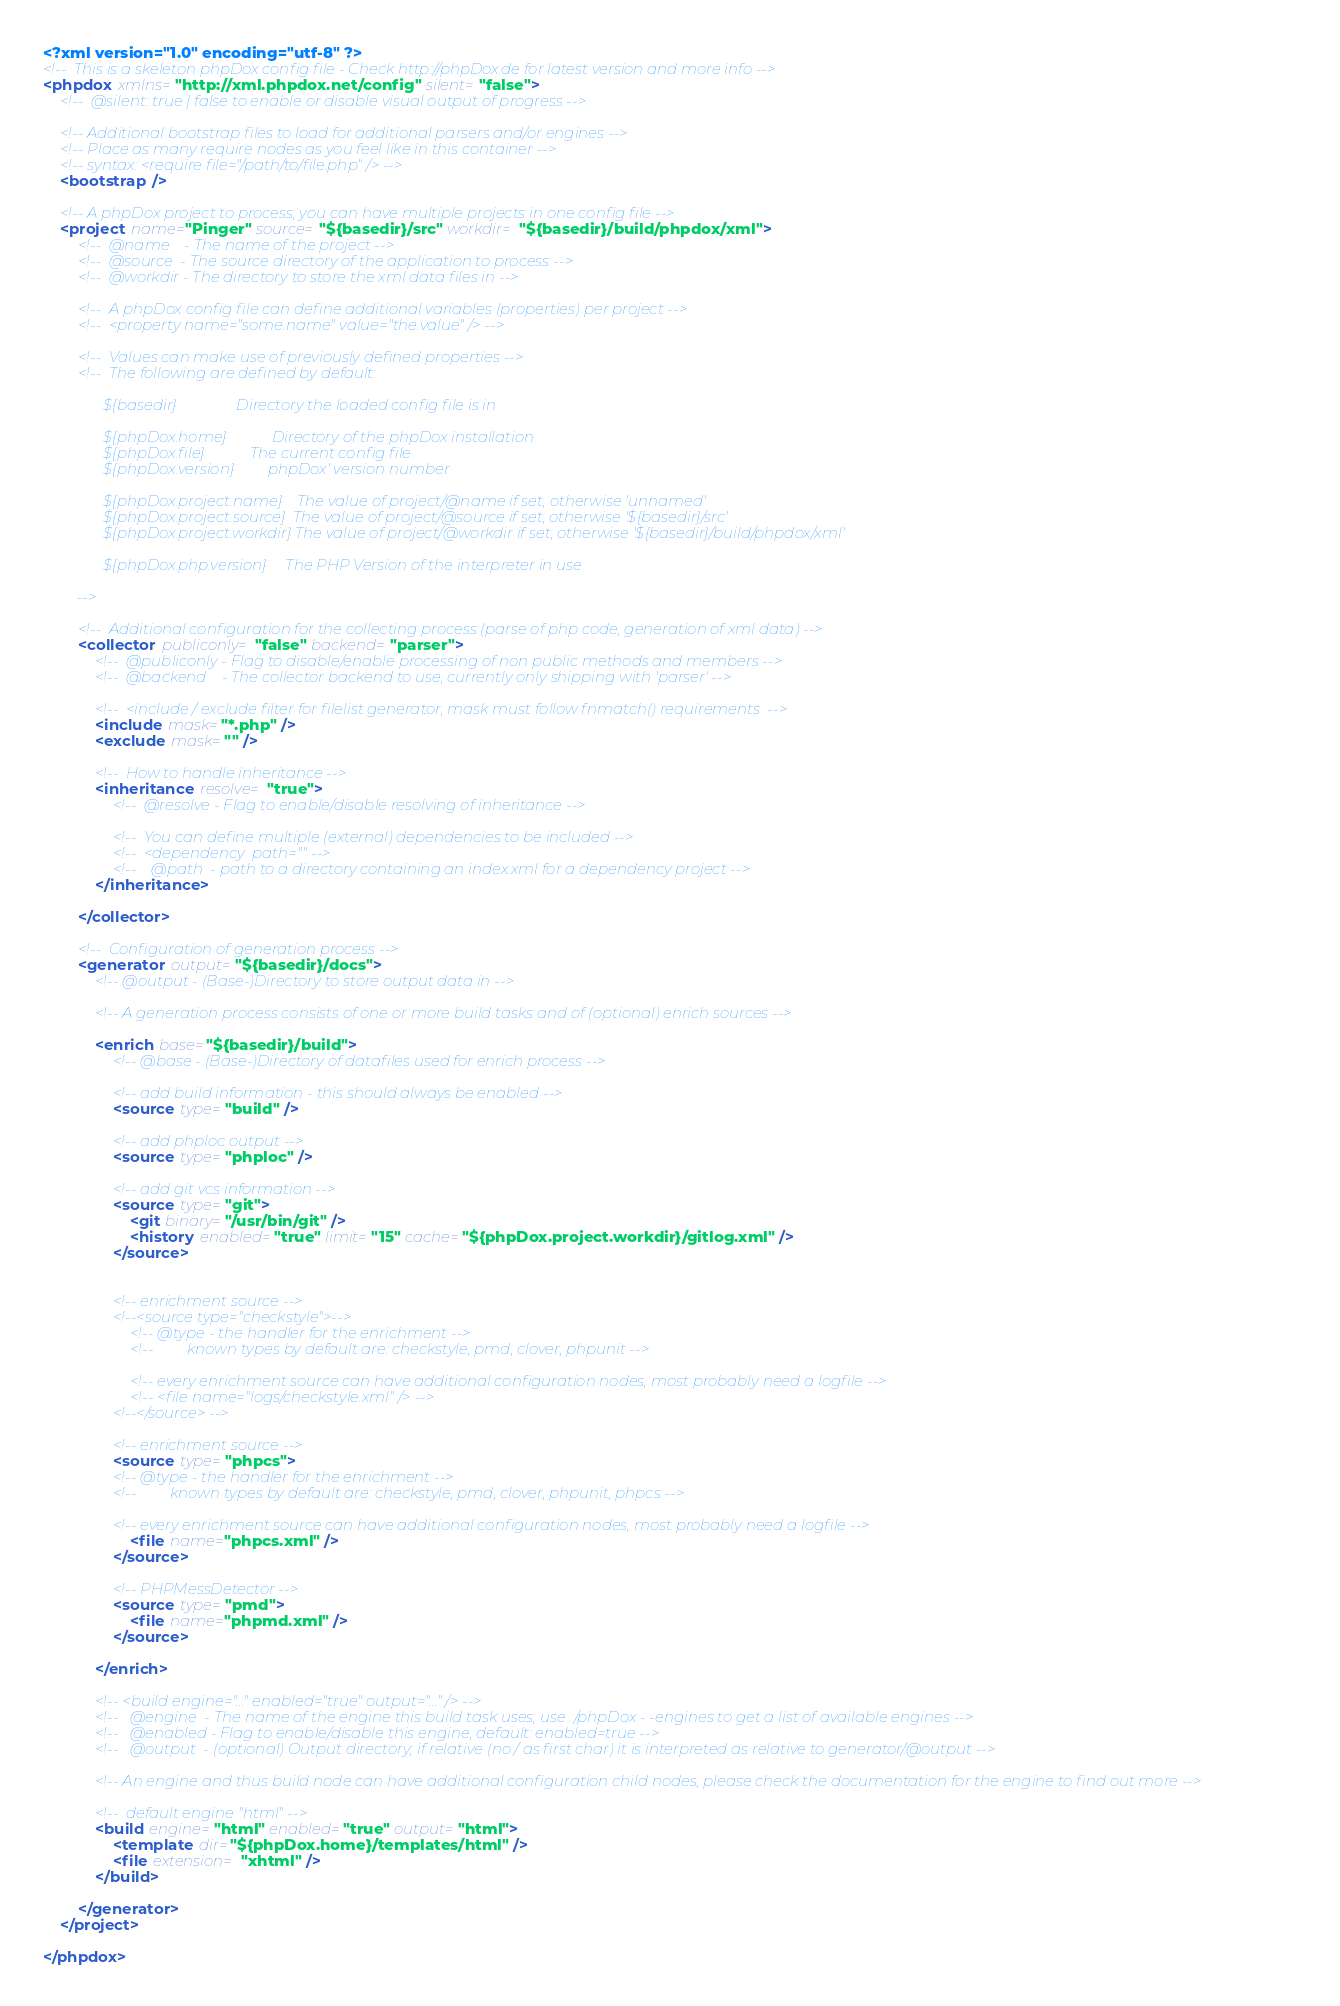Convert code to text. <code><loc_0><loc_0><loc_500><loc_500><_XML_><?xml version="1.0" encoding="utf-8" ?>
<!--  This is a skeleton phpDox config file - Check http://phpDox.de for latest version and more info -->
<phpdox xmlns="http://xml.phpdox.net/config" silent="false">
    <!--  @silent: true | false to enable or disable visual output of progress -->

    <!-- Additional bootstrap files to load for additional parsers and/or engines -->
    <!-- Place as many require nodes as you feel like in this container -->
    <!-- syntax: <require file="/path/to/file.php" /> -->
    <bootstrap />

    <!-- A phpDox project to process, you can have multiple projects in one config file -->
    <project name="Pinger" source="${basedir}/src" workdir="${basedir}/build/phpdox/xml">
        <!--  @name    - The name of the project -->
        <!--  @source  - The source directory of the application to process -->
        <!--  @workdir - The directory to store the xml data files in -->

        <!--  A phpDox config file can define additional variables (properties) per project -->
        <!--  <property name="some.name" value="the.value" /> -->

        <!--  Values can make use of previously defined properties -->
        <!--  The following are defined by default:

                ${basedir}                Directory the loaded config file is in

                ${phpDox.home}            Directory of the phpDox installation
                ${phpDox.file}            The current config file
                ${phpDox.version}         phpDox' version number

                ${phpDox.project.name}    The value of project/@name if set, otherwise 'unnamed'
                ${phpDox.project.source}  The value of project/@source if set, otherwise '${basedir}/src'
                ${phpDox.project.workdir} The value of project/@workdir if set, otherwise '${basedir}/build/phpdox/xml'

                ${phpDox.php.version}     The PHP Version of the interpreter in use

         -->

        <!--  Additional configuration for the collecting process (parse of php code, generation of xml data) -->
        <collector publiconly="false" backend="parser">
            <!--  @publiconly - Flag to disable/enable processing of non public methods and members -->
            <!--  @backend    - The collector backend to use, currently only shipping with 'parser' -->

            <!--  <include / exclude filter for filelist generator, mask must follow fnmatch() requirements  -->
            <include mask="*.php" />
            <exclude mask="" />

            <!--  How to handle inheritance -->
            <inheritance resolve="true">
                <!--  @resolve - Flag to enable/disable resolving of inheritance -->

                <!--  You can define multiple (external) dependencies to be included -->
                <!--  <dependency  path="" -->
                <!--    @path  - path to a directory containing an index.xml for a dependency project -->
            </inheritance>

        </collector>

        <!--  Configuration of generation process -->
        <generator output="${basedir}/docs">
            <!-- @output - (Base-)Directory to store output data in -->

            <!-- A generation process consists of one or more build tasks and of (optional) enrich sources -->

            <enrich base="${basedir}/build">
                <!-- @base - (Base-)Directory of datafiles used for enrich process -->

                <!-- add build information - this should always be enabled -->
                <source type="build" />

                <!-- add phploc output -->
                <source type="phploc" />

                <!-- add git vcs information -->
                <source type="git">
                    <git binary="/usr/bin/git" />
                    <history enabled="true" limit="15" cache="${phpDox.project.workdir}/gitlog.xml" />
                </source>


                <!-- enrichment source -->
                <!--<source type="checkstyle">-->
                    <!-- @type - the handler for the enrichment -->
                    <!--         known types by default are: checkstyle, pmd, clover, phpunit -->

                    <!-- every enrichment source can have additional configuration nodes, most probably need a logfile -->
                    <!-- <file name="logs/checkstyle.xml" /> -->
                <!--</source> -->

                <!-- enrichment source -->
                <source type="phpcs">
                <!-- @type - the handler for the enrichment -->
                <!--         known types by default are: checkstyle, pmd, clover, phpunit, phpcs -->

                <!-- every enrichment source can have additional configuration nodes, most probably need a logfile -->
                    <file name="phpcs.xml" />
                </source>

                <!-- PHPMessDetector -->
                <source type="pmd">
                    <file name="phpmd.xml" />
                </source>

            </enrich>

            <!-- <build engine="..." enabled="true" output="..." /> -->
            <!--   @engine  - The name of the engine this build task uses, use ./phpDox - -engines to get a list of available engines -->
            <!--   @enabled - Flag to enable/disable this engine, default: enabled=true -->
            <!--   @output  - (optional) Output directory; if relative (no / as first char) it is interpreted as relative to generator/@output -->

            <!-- An engine and thus build node can have additional configuration child nodes, please check the documentation for the engine to find out more -->

            <!--  default engine "html" -->
            <build engine="html" enabled="true" output="html">
                <template dir="${phpDox.home}/templates/html" />
                <file extension="xhtml" />
            </build>

        </generator>
    </project>

</phpdox>
</code> 